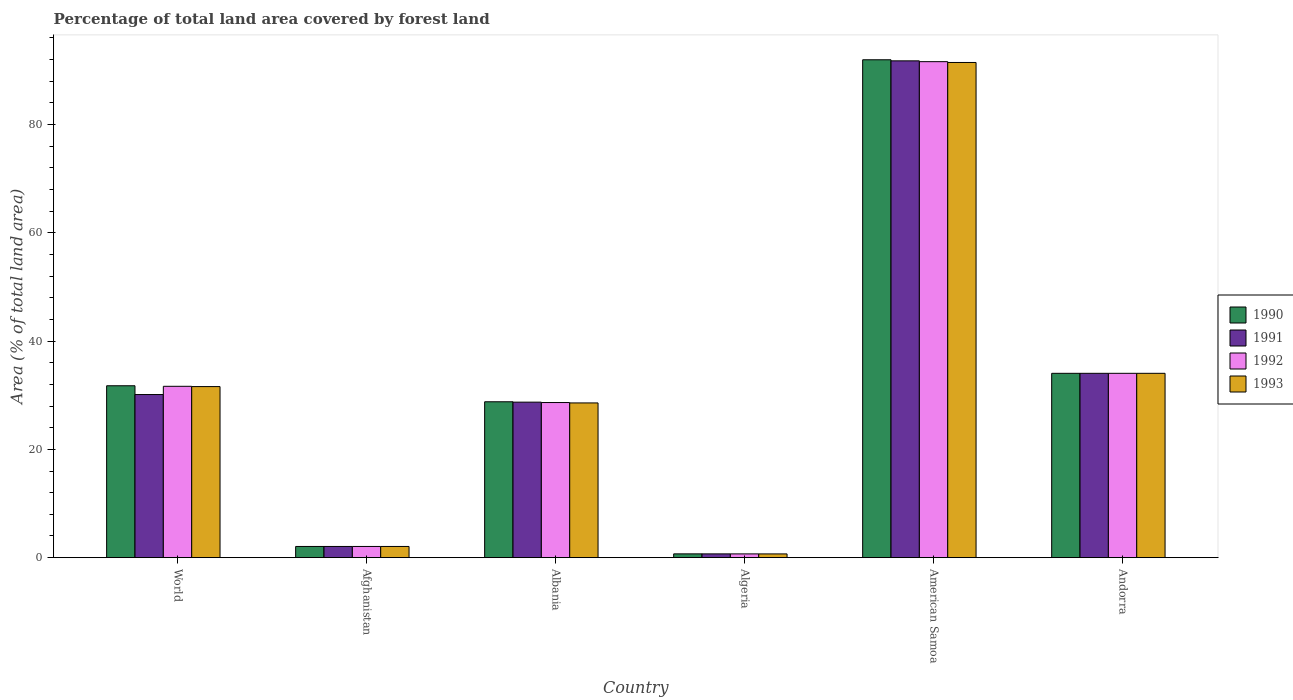How many different coloured bars are there?
Provide a succinct answer. 4. How many groups of bars are there?
Your answer should be compact. 6. Are the number of bars per tick equal to the number of legend labels?
Offer a very short reply. Yes. How many bars are there on the 6th tick from the left?
Your response must be concise. 4. How many bars are there on the 2nd tick from the right?
Keep it short and to the point. 4. What is the label of the 3rd group of bars from the left?
Offer a terse response. Albania. In how many cases, is the number of bars for a given country not equal to the number of legend labels?
Provide a succinct answer. 0. What is the percentage of forest land in 1993 in Albania?
Offer a very short reply. 28.57. Across all countries, what is the maximum percentage of forest land in 1990?
Offer a terse response. 91.95. Across all countries, what is the minimum percentage of forest land in 1992?
Keep it short and to the point. 0.69. In which country was the percentage of forest land in 1991 maximum?
Your answer should be compact. American Samoa. In which country was the percentage of forest land in 1993 minimum?
Offer a very short reply. Algeria. What is the total percentage of forest land in 1991 in the graph?
Give a very brief answer. 187.4. What is the difference between the percentage of forest land in 1993 in Afghanistan and that in World?
Give a very brief answer. -29.53. What is the difference between the percentage of forest land in 1991 in American Samoa and the percentage of forest land in 1990 in Algeria?
Your response must be concise. 91.05. What is the average percentage of forest land in 1993 per country?
Offer a terse response. 31.4. In how many countries, is the percentage of forest land in 1993 greater than 16 %?
Give a very brief answer. 4. What is the ratio of the percentage of forest land in 1991 in Afghanistan to that in World?
Give a very brief answer. 0.07. Is the percentage of forest land in 1991 in Albania less than that in Algeria?
Your answer should be compact. No. Is the difference between the percentage of forest land in 1990 in Afghanistan and Albania greater than the difference between the percentage of forest land in 1991 in Afghanistan and Albania?
Offer a very short reply. No. What is the difference between the highest and the second highest percentage of forest land in 1990?
Keep it short and to the point. -57.91. What is the difference between the highest and the lowest percentage of forest land in 1991?
Make the answer very short. 91.05. What does the 1st bar from the left in Afghanistan represents?
Keep it short and to the point. 1990. How many countries are there in the graph?
Your response must be concise. 6. Are the values on the major ticks of Y-axis written in scientific E-notation?
Provide a short and direct response. No. Does the graph contain any zero values?
Make the answer very short. No. Where does the legend appear in the graph?
Provide a short and direct response. Center right. How are the legend labels stacked?
Offer a terse response. Vertical. What is the title of the graph?
Offer a very short reply. Percentage of total land area covered by forest land. Does "1990" appear as one of the legend labels in the graph?
Make the answer very short. Yes. What is the label or title of the X-axis?
Make the answer very short. Country. What is the label or title of the Y-axis?
Ensure brevity in your answer.  Area (% of total land area). What is the Area (% of total land area) of 1990 in World?
Your response must be concise. 31.75. What is the Area (% of total land area) of 1991 in World?
Ensure brevity in your answer.  30.12. What is the Area (% of total land area) in 1992 in World?
Give a very brief answer. 31.64. What is the Area (% of total land area) of 1993 in World?
Ensure brevity in your answer.  31.59. What is the Area (% of total land area) of 1990 in Afghanistan?
Your answer should be compact. 2.07. What is the Area (% of total land area) in 1991 in Afghanistan?
Provide a succinct answer. 2.07. What is the Area (% of total land area) of 1992 in Afghanistan?
Your answer should be compact. 2.07. What is the Area (% of total land area) in 1993 in Afghanistan?
Ensure brevity in your answer.  2.07. What is the Area (% of total land area) of 1990 in Albania?
Your answer should be compact. 28.79. What is the Area (% of total land area) in 1991 in Albania?
Make the answer very short. 28.72. What is the Area (% of total land area) in 1992 in Albania?
Make the answer very short. 28.65. What is the Area (% of total land area) in 1993 in Albania?
Make the answer very short. 28.57. What is the Area (% of total land area) in 1990 in Algeria?
Ensure brevity in your answer.  0.7. What is the Area (% of total land area) of 1991 in Algeria?
Keep it short and to the point. 0.7. What is the Area (% of total land area) in 1992 in Algeria?
Your answer should be compact. 0.69. What is the Area (% of total land area) of 1993 in Algeria?
Make the answer very short. 0.69. What is the Area (% of total land area) of 1990 in American Samoa?
Give a very brief answer. 91.95. What is the Area (% of total land area) of 1991 in American Samoa?
Offer a terse response. 91.75. What is the Area (% of total land area) in 1992 in American Samoa?
Offer a very short reply. 91.6. What is the Area (% of total land area) in 1993 in American Samoa?
Ensure brevity in your answer.  91.45. What is the Area (% of total land area) in 1990 in Andorra?
Ensure brevity in your answer.  34.04. What is the Area (% of total land area) of 1991 in Andorra?
Give a very brief answer. 34.04. What is the Area (% of total land area) in 1992 in Andorra?
Offer a terse response. 34.04. What is the Area (% of total land area) of 1993 in Andorra?
Give a very brief answer. 34.04. Across all countries, what is the maximum Area (% of total land area) in 1990?
Your answer should be compact. 91.95. Across all countries, what is the maximum Area (% of total land area) of 1991?
Your answer should be very brief. 91.75. Across all countries, what is the maximum Area (% of total land area) of 1992?
Offer a very short reply. 91.6. Across all countries, what is the maximum Area (% of total land area) of 1993?
Offer a terse response. 91.45. Across all countries, what is the minimum Area (% of total land area) in 1990?
Your answer should be compact. 0.7. Across all countries, what is the minimum Area (% of total land area) of 1991?
Give a very brief answer. 0.7. Across all countries, what is the minimum Area (% of total land area) of 1992?
Make the answer very short. 0.69. Across all countries, what is the minimum Area (% of total land area) of 1993?
Provide a succinct answer. 0.69. What is the total Area (% of total land area) in 1990 in the graph?
Ensure brevity in your answer.  189.29. What is the total Area (% of total land area) of 1991 in the graph?
Offer a very short reply. 187.4. What is the total Area (% of total land area) of 1992 in the graph?
Your response must be concise. 188.69. What is the total Area (% of total land area) in 1993 in the graph?
Your answer should be very brief. 188.42. What is the difference between the Area (% of total land area) of 1990 in World and that in Afghanistan?
Provide a short and direct response. 29.68. What is the difference between the Area (% of total land area) in 1991 in World and that in Afghanistan?
Offer a very short reply. 28.06. What is the difference between the Area (% of total land area) in 1992 in World and that in Afghanistan?
Offer a very short reply. 29.58. What is the difference between the Area (% of total land area) of 1993 in World and that in Afghanistan?
Your response must be concise. 29.53. What is the difference between the Area (% of total land area) of 1990 in World and that in Albania?
Your answer should be compact. 2.96. What is the difference between the Area (% of total land area) of 1991 in World and that in Albania?
Ensure brevity in your answer.  1.41. What is the difference between the Area (% of total land area) of 1992 in World and that in Albania?
Offer a terse response. 3. What is the difference between the Area (% of total land area) in 1993 in World and that in Albania?
Ensure brevity in your answer.  3.02. What is the difference between the Area (% of total land area) of 1990 in World and that in Algeria?
Ensure brevity in your answer.  31.05. What is the difference between the Area (% of total land area) in 1991 in World and that in Algeria?
Make the answer very short. 29.43. What is the difference between the Area (% of total land area) in 1992 in World and that in Algeria?
Provide a succinct answer. 30.95. What is the difference between the Area (% of total land area) in 1993 in World and that in Algeria?
Offer a very short reply. 30.91. What is the difference between the Area (% of total land area) of 1990 in World and that in American Samoa?
Give a very brief answer. -60.2. What is the difference between the Area (% of total land area) of 1991 in World and that in American Samoa?
Make the answer very short. -61.63. What is the difference between the Area (% of total land area) of 1992 in World and that in American Samoa?
Your answer should be compact. -59.96. What is the difference between the Area (% of total land area) of 1993 in World and that in American Samoa?
Ensure brevity in your answer.  -59.86. What is the difference between the Area (% of total land area) of 1990 in World and that in Andorra?
Your response must be concise. -2.3. What is the difference between the Area (% of total land area) of 1991 in World and that in Andorra?
Offer a very short reply. -3.92. What is the difference between the Area (% of total land area) of 1992 in World and that in Andorra?
Give a very brief answer. -2.4. What is the difference between the Area (% of total land area) of 1993 in World and that in Andorra?
Make the answer very short. -2.45. What is the difference between the Area (% of total land area) of 1990 in Afghanistan and that in Albania?
Give a very brief answer. -26.72. What is the difference between the Area (% of total land area) in 1991 in Afghanistan and that in Albania?
Give a very brief answer. -26.65. What is the difference between the Area (% of total land area) in 1992 in Afghanistan and that in Albania?
Give a very brief answer. -26.58. What is the difference between the Area (% of total land area) in 1993 in Afghanistan and that in Albania?
Provide a short and direct response. -26.51. What is the difference between the Area (% of total land area) in 1990 in Afghanistan and that in Algeria?
Offer a very short reply. 1.37. What is the difference between the Area (% of total land area) in 1991 in Afghanistan and that in Algeria?
Ensure brevity in your answer.  1.37. What is the difference between the Area (% of total land area) of 1992 in Afghanistan and that in Algeria?
Your answer should be compact. 1.38. What is the difference between the Area (% of total land area) in 1993 in Afghanistan and that in Algeria?
Offer a terse response. 1.38. What is the difference between the Area (% of total land area) in 1990 in Afghanistan and that in American Samoa?
Your answer should be compact. -89.88. What is the difference between the Area (% of total land area) of 1991 in Afghanistan and that in American Samoa?
Ensure brevity in your answer.  -89.68. What is the difference between the Area (% of total land area) in 1992 in Afghanistan and that in American Samoa?
Offer a terse response. -89.53. What is the difference between the Area (% of total land area) of 1993 in Afghanistan and that in American Samoa?
Provide a succinct answer. -89.38. What is the difference between the Area (% of total land area) of 1990 in Afghanistan and that in Andorra?
Provide a succinct answer. -31.97. What is the difference between the Area (% of total land area) in 1991 in Afghanistan and that in Andorra?
Provide a succinct answer. -31.97. What is the difference between the Area (% of total land area) of 1992 in Afghanistan and that in Andorra?
Offer a terse response. -31.97. What is the difference between the Area (% of total land area) of 1993 in Afghanistan and that in Andorra?
Your answer should be very brief. -31.97. What is the difference between the Area (% of total land area) of 1990 in Albania and that in Algeria?
Offer a very short reply. 28.09. What is the difference between the Area (% of total land area) of 1991 in Albania and that in Algeria?
Offer a terse response. 28.02. What is the difference between the Area (% of total land area) in 1992 in Albania and that in Algeria?
Your answer should be very brief. 27.95. What is the difference between the Area (% of total land area) in 1993 in Albania and that in Algeria?
Ensure brevity in your answer.  27.89. What is the difference between the Area (% of total land area) of 1990 in Albania and that in American Samoa?
Your answer should be compact. -63.16. What is the difference between the Area (% of total land area) in 1991 in Albania and that in American Samoa?
Your answer should be compact. -63.03. What is the difference between the Area (% of total land area) of 1992 in Albania and that in American Samoa?
Your answer should be compact. -62.95. What is the difference between the Area (% of total land area) of 1993 in Albania and that in American Samoa?
Provide a succinct answer. -62.88. What is the difference between the Area (% of total land area) in 1990 in Albania and that in Andorra?
Your response must be concise. -5.25. What is the difference between the Area (% of total land area) of 1991 in Albania and that in Andorra?
Give a very brief answer. -5.33. What is the difference between the Area (% of total land area) of 1992 in Albania and that in Andorra?
Keep it short and to the point. -5.4. What is the difference between the Area (% of total land area) of 1993 in Albania and that in Andorra?
Ensure brevity in your answer.  -5.47. What is the difference between the Area (% of total land area) of 1990 in Algeria and that in American Samoa?
Your answer should be compact. -91.25. What is the difference between the Area (% of total land area) of 1991 in Algeria and that in American Samoa?
Give a very brief answer. -91.05. What is the difference between the Area (% of total land area) of 1992 in Algeria and that in American Samoa?
Your response must be concise. -90.91. What is the difference between the Area (% of total land area) in 1993 in Algeria and that in American Samoa?
Offer a terse response. -90.76. What is the difference between the Area (% of total land area) of 1990 in Algeria and that in Andorra?
Provide a succinct answer. -33.34. What is the difference between the Area (% of total land area) of 1991 in Algeria and that in Andorra?
Make the answer very short. -33.35. What is the difference between the Area (% of total land area) of 1992 in Algeria and that in Andorra?
Keep it short and to the point. -33.35. What is the difference between the Area (% of total land area) of 1993 in Algeria and that in Andorra?
Your response must be concise. -33.35. What is the difference between the Area (% of total land area) in 1990 in American Samoa and that in Andorra?
Keep it short and to the point. 57.91. What is the difference between the Area (% of total land area) in 1991 in American Samoa and that in Andorra?
Ensure brevity in your answer.  57.71. What is the difference between the Area (% of total land area) of 1992 in American Samoa and that in Andorra?
Offer a terse response. 57.56. What is the difference between the Area (% of total land area) of 1993 in American Samoa and that in Andorra?
Offer a terse response. 57.41. What is the difference between the Area (% of total land area) in 1990 in World and the Area (% of total land area) in 1991 in Afghanistan?
Provide a succinct answer. 29.68. What is the difference between the Area (% of total land area) of 1990 in World and the Area (% of total land area) of 1992 in Afghanistan?
Give a very brief answer. 29.68. What is the difference between the Area (% of total land area) of 1990 in World and the Area (% of total land area) of 1993 in Afghanistan?
Provide a succinct answer. 29.68. What is the difference between the Area (% of total land area) of 1991 in World and the Area (% of total land area) of 1992 in Afghanistan?
Give a very brief answer. 28.06. What is the difference between the Area (% of total land area) of 1991 in World and the Area (% of total land area) of 1993 in Afghanistan?
Provide a short and direct response. 28.06. What is the difference between the Area (% of total land area) of 1992 in World and the Area (% of total land area) of 1993 in Afghanistan?
Make the answer very short. 29.58. What is the difference between the Area (% of total land area) of 1990 in World and the Area (% of total land area) of 1991 in Albania?
Offer a very short reply. 3.03. What is the difference between the Area (% of total land area) in 1990 in World and the Area (% of total land area) in 1992 in Albania?
Keep it short and to the point. 3.1. What is the difference between the Area (% of total land area) of 1990 in World and the Area (% of total land area) of 1993 in Albania?
Your answer should be very brief. 3.17. What is the difference between the Area (% of total land area) of 1991 in World and the Area (% of total land area) of 1992 in Albania?
Ensure brevity in your answer.  1.48. What is the difference between the Area (% of total land area) of 1991 in World and the Area (% of total land area) of 1993 in Albania?
Your response must be concise. 1.55. What is the difference between the Area (% of total land area) in 1992 in World and the Area (% of total land area) in 1993 in Albania?
Your response must be concise. 3.07. What is the difference between the Area (% of total land area) of 1990 in World and the Area (% of total land area) of 1991 in Algeria?
Make the answer very short. 31.05. What is the difference between the Area (% of total land area) of 1990 in World and the Area (% of total land area) of 1992 in Algeria?
Keep it short and to the point. 31.05. What is the difference between the Area (% of total land area) of 1990 in World and the Area (% of total land area) of 1993 in Algeria?
Make the answer very short. 31.06. What is the difference between the Area (% of total land area) of 1991 in World and the Area (% of total land area) of 1992 in Algeria?
Your answer should be compact. 29.43. What is the difference between the Area (% of total land area) of 1991 in World and the Area (% of total land area) of 1993 in Algeria?
Provide a succinct answer. 29.44. What is the difference between the Area (% of total land area) in 1992 in World and the Area (% of total land area) in 1993 in Algeria?
Ensure brevity in your answer.  30.96. What is the difference between the Area (% of total land area) of 1990 in World and the Area (% of total land area) of 1991 in American Samoa?
Provide a short and direct response. -60. What is the difference between the Area (% of total land area) in 1990 in World and the Area (% of total land area) in 1992 in American Samoa?
Ensure brevity in your answer.  -59.85. What is the difference between the Area (% of total land area) of 1990 in World and the Area (% of total land area) of 1993 in American Samoa?
Keep it short and to the point. -59.7. What is the difference between the Area (% of total land area) of 1991 in World and the Area (% of total land area) of 1992 in American Samoa?
Ensure brevity in your answer.  -61.48. What is the difference between the Area (% of total land area) in 1991 in World and the Area (% of total land area) in 1993 in American Samoa?
Your answer should be very brief. -61.33. What is the difference between the Area (% of total land area) of 1992 in World and the Area (% of total land area) of 1993 in American Samoa?
Offer a terse response. -59.81. What is the difference between the Area (% of total land area) of 1990 in World and the Area (% of total land area) of 1991 in Andorra?
Offer a very short reply. -2.3. What is the difference between the Area (% of total land area) in 1990 in World and the Area (% of total land area) in 1992 in Andorra?
Your answer should be compact. -2.3. What is the difference between the Area (% of total land area) of 1990 in World and the Area (% of total land area) of 1993 in Andorra?
Keep it short and to the point. -2.3. What is the difference between the Area (% of total land area) in 1991 in World and the Area (% of total land area) in 1992 in Andorra?
Offer a very short reply. -3.92. What is the difference between the Area (% of total land area) of 1991 in World and the Area (% of total land area) of 1993 in Andorra?
Make the answer very short. -3.92. What is the difference between the Area (% of total land area) of 1992 in World and the Area (% of total land area) of 1993 in Andorra?
Make the answer very short. -2.4. What is the difference between the Area (% of total land area) of 1990 in Afghanistan and the Area (% of total land area) of 1991 in Albania?
Give a very brief answer. -26.65. What is the difference between the Area (% of total land area) in 1990 in Afghanistan and the Area (% of total land area) in 1992 in Albania?
Provide a short and direct response. -26.58. What is the difference between the Area (% of total land area) in 1990 in Afghanistan and the Area (% of total land area) in 1993 in Albania?
Give a very brief answer. -26.51. What is the difference between the Area (% of total land area) of 1991 in Afghanistan and the Area (% of total land area) of 1992 in Albania?
Your answer should be very brief. -26.58. What is the difference between the Area (% of total land area) in 1991 in Afghanistan and the Area (% of total land area) in 1993 in Albania?
Your response must be concise. -26.51. What is the difference between the Area (% of total land area) of 1992 in Afghanistan and the Area (% of total land area) of 1993 in Albania?
Provide a short and direct response. -26.51. What is the difference between the Area (% of total land area) in 1990 in Afghanistan and the Area (% of total land area) in 1991 in Algeria?
Give a very brief answer. 1.37. What is the difference between the Area (% of total land area) of 1990 in Afghanistan and the Area (% of total land area) of 1992 in Algeria?
Keep it short and to the point. 1.38. What is the difference between the Area (% of total land area) in 1990 in Afghanistan and the Area (% of total land area) in 1993 in Algeria?
Ensure brevity in your answer.  1.38. What is the difference between the Area (% of total land area) in 1991 in Afghanistan and the Area (% of total land area) in 1992 in Algeria?
Provide a succinct answer. 1.38. What is the difference between the Area (% of total land area) of 1991 in Afghanistan and the Area (% of total land area) of 1993 in Algeria?
Your response must be concise. 1.38. What is the difference between the Area (% of total land area) in 1992 in Afghanistan and the Area (% of total land area) in 1993 in Algeria?
Your answer should be very brief. 1.38. What is the difference between the Area (% of total land area) of 1990 in Afghanistan and the Area (% of total land area) of 1991 in American Samoa?
Offer a very short reply. -89.68. What is the difference between the Area (% of total land area) in 1990 in Afghanistan and the Area (% of total land area) in 1992 in American Samoa?
Your answer should be very brief. -89.53. What is the difference between the Area (% of total land area) of 1990 in Afghanistan and the Area (% of total land area) of 1993 in American Samoa?
Ensure brevity in your answer.  -89.38. What is the difference between the Area (% of total land area) in 1991 in Afghanistan and the Area (% of total land area) in 1992 in American Samoa?
Offer a very short reply. -89.53. What is the difference between the Area (% of total land area) of 1991 in Afghanistan and the Area (% of total land area) of 1993 in American Samoa?
Your response must be concise. -89.38. What is the difference between the Area (% of total land area) of 1992 in Afghanistan and the Area (% of total land area) of 1993 in American Samoa?
Keep it short and to the point. -89.38. What is the difference between the Area (% of total land area) in 1990 in Afghanistan and the Area (% of total land area) in 1991 in Andorra?
Ensure brevity in your answer.  -31.97. What is the difference between the Area (% of total land area) in 1990 in Afghanistan and the Area (% of total land area) in 1992 in Andorra?
Your answer should be very brief. -31.97. What is the difference between the Area (% of total land area) in 1990 in Afghanistan and the Area (% of total land area) in 1993 in Andorra?
Ensure brevity in your answer.  -31.97. What is the difference between the Area (% of total land area) of 1991 in Afghanistan and the Area (% of total land area) of 1992 in Andorra?
Offer a very short reply. -31.97. What is the difference between the Area (% of total land area) of 1991 in Afghanistan and the Area (% of total land area) of 1993 in Andorra?
Offer a terse response. -31.97. What is the difference between the Area (% of total land area) of 1992 in Afghanistan and the Area (% of total land area) of 1993 in Andorra?
Your response must be concise. -31.97. What is the difference between the Area (% of total land area) in 1990 in Albania and the Area (% of total land area) in 1991 in Algeria?
Offer a very short reply. 28.09. What is the difference between the Area (% of total land area) in 1990 in Albania and the Area (% of total land area) in 1992 in Algeria?
Make the answer very short. 28.1. What is the difference between the Area (% of total land area) of 1990 in Albania and the Area (% of total land area) of 1993 in Algeria?
Ensure brevity in your answer.  28.1. What is the difference between the Area (% of total land area) in 1991 in Albania and the Area (% of total land area) in 1992 in Algeria?
Your answer should be compact. 28.02. What is the difference between the Area (% of total land area) of 1991 in Albania and the Area (% of total land area) of 1993 in Algeria?
Provide a succinct answer. 28.03. What is the difference between the Area (% of total land area) in 1992 in Albania and the Area (% of total land area) in 1993 in Algeria?
Offer a very short reply. 27.96. What is the difference between the Area (% of total land area) in 1990 in Albania and the Area (% of total land area) in 1991 in American Samoa?
Make the answer very short. -62.96. What is the difference between the Area (% of total land area) of 1990 in Albania and the Area (% of total land area) of 1992 in American Samoa?
Give a very brief answer. -62.81. What is the difference between the Area (% of total land area) in 1990 in Albania and the Area (% of total land area) in 1993 in American Samoa?
Ensure brevity in your answer.  -62.66. What is the difference between the Area (% of total land area) in 1991 in Albania and the Area (% of total land area) in 1992 in American Samoa?
Make the answer very short. -62.88. What is the difference between the Area (% of total land area) in 1991 in Albania and the Area (% of total land area) in 1993 in American Samoa?
Provide a short and direct response. -62.73. What is the difference between the Area (% of total land area) of 1992 in Albania and the Area (% of total land area) of 1993 in American Samoa?
Make the answer very short. -62.8. What is the difference between the Area (% of total land area) of 1990 in Albania and the Area (% of total land area) of 1991 in Andorra?
Ensure brevity in your answer.  -5.25. What is the difference between the Area (% of total land area) of 1990 in Albania and the Area (% of total land area) of 1992 in Andorra?
Make the answer very short. -5.25. What is the difference between the Area (% of total land area) in 1990 in Albania and the Area (% of total land area) in 1993 in Andorra?
Give a very brief answer. -5.25. What is the difference between the Area (% of total land area) of 1991 in Albania and the Area (% of total land area) of 1992 in Andorra?
Offer a very short reply. -5.33. What is the difference between the Area (% of total land area) of 1991 in Albania and the Area (% of total land area) of 1993 in Andorra?
Your answer should be compact. -5.33. What is the difference between the Area (% of total land area) of 1992 in Albania and the Area (% of total land area) of 1993 in Andorra?
Your answer should be very brief. -5.4. What is the difference between the Area (% of total land area) in 1990 in Algeria and the Area (% of total land area) in 1991 in American Samoa?
Offer a terse response. -91.05. What is the difference between the Area (% of total land area) of 1990 in Algeria and the Area (% of total land area) of 1992 in American Samoa?
Provide a succinct answer. -90.9. What is the difference between the Area (% of total land area) in 1990 in Algeria and the Area (% of total land area) in 1993 in American Samoa?
Your answer should be compact. -90.75. What is the difference between the Area (% of total land area) of 1991 in Algeria and the Area (% of total land area) of 1992 in American Samoa?
Your answer should be compact. -90.9. What is the difference between the Area (% of total land area) in 1991 in Algeria and the Area (% of total land area) in 1993 in American Samoa?
Offer a very short reply. -90.75. What is the difference between the Area (% of total land area) of 1992 in Algeria and the Area (% of total land area) of 1993 in American Samoa?
Offer a terse response. -90.76. What is the difference between the Area (% of total land area) in 1990 in Algeria and the Area (% of total land area) in 1991 in Andorra?
Give a very brief answer. -33.34. What is the difference between the Area (% of total land area) of 1990 in Algeria and the Area (% of total land area) of 1992 in Andorra?
Offer a very short reply. -33.34. What is the difference between the Area (% of total land area) in 1990 in Algeria and the Area (% of total land area) in 1993 in Andorra?
Offer a very short reply. -33.34. What is the difference between the Area (% of total land area) of 1991 in Algeria and the Area (% of total land area) of 1992 in Andorra?
Offer a terse response. -33.35. What is the difference between the Area (% of total land area) in 1991 in Algeria and the Area (% of total land area) in 1993 in Andorra?
Keep it short and to the point. -33.35. What is the difference between the Area (% of total land area) of 1992 in Algeria and the Area (% of total land area) of 1993 in Andorra?
Make the answer very short. -33.35. What is the difference between the Area (% of total land area) of 1990 in American Samoa and the Area (% of total land area) of 1991 in Andorra?
Ensure brevity in your answer.  57.91. What is the difference between the Area (% of total land area) in 1990 in American Samoa and the Area (% of total land area) in 1992 in Andorra?
Provide a short and direct response. 57.91. What is the difference between the Area (% of total land area) of 1990 in American Samoa and the Area (% of total land area) of 1993 in Andorra?
Give a very brief answer. 57.91. What is the difference between the Area (% of total land area) in 1991 in American Samoa and the Area (% of total land area) in 1992 in Andorra?
Provide a short and direct response. 57.71. What is the difference between the Area (% of total land area) of 1991 in American Samoa and the Area (% of total land area) of 1993 in Andorra?
Ensure brevity in your answer.  57.71. What is the difference between the Area (% of total land area) of 1992 in American Samoa and the Area (% of total land area) of 1993 in Andorra?
Your answer should be very brief. 57.56. What is the average Area (% of total land area) of 1990 per country?
Provide a short and direct response. 31.55. What is the average Area (% of total land area) of 1991 per country?
Give a very brief answer. 31.23. What is the average Area (% of total land area) of 1992 per country?
Keep it short and to the point. 31.45. What is the average Area (% of total land area) of 1993 per country?
Ensure brevity in your answer.  31.4. What is the difference between the Area (% of total land area) of 1990 and Area (% of total land area) of 1991 in World?
Your answer should be very brief. 1.62. What is the difference between the Area (% of total land area) of 1990 and Area (% of total land area) of 1992 in World?
Give a very brief answer. 0.1. What is the difference between the Area (% of total land area) in 1990 and Area (% of total land area) in 1993 in World?
Offer a terse response. 0.15. What is the difference between the Area (% of total land area) in 1991 and Area (% of total land area) in 1992 in World?
Provide a succinct answer. -1.52. What is the difference between the Area (% of total land area) in 1991 and Area (% of total land area) in 1993 in World?
Your response must be concise. -1.47. What is the difference between the Area (% of total land area) of 1992 and Area (% of total land area) of 1993 in World?
Provide a short and direct response. 0.05. What is the difference between the Area (% of total land area) of 1990 and Area (% of total land area) of 1991 in Afghanistan?
Provide a short and direct response. 0. What is the difference between the Area (% of total land area) of 1990 and Area (% of total land area) of 1992 in Afghanistan?
Your answer should be very brief. 0. What is the difference between the Area (% of total land area) in 1990 and Area (% of total land area) in 1993 in Afghanistan?
Give a very brief answer. 0. What is the difference between the Area (% of total land area) in 1991 and Area (% of total land area) in 1993 in Afghanistan?
Provide a succinct answer. 0. What is the difference between the Area (% of total land area) in 1992 and Area (% of total land area) in 1993 in Afghanistan?
Your response must be concise. 0. What is the difference between the Area (% of total land area) in 1990 and Area (% of total land area) in 1991 in Albania?
Provide a succinct answer. 0.07. What is the difference between the Area (% of total land area) of 1990 and Area (% of total land area) of 1992 in Albania?
Provide a short and direct response. 0.14. What is the difference between the Area (% of total land area) in 1990 and Area (% of total land area) in 1993 in Albania?
Offer a very short reply. 0.21. What is the difference between the Area (% of total land area) of 1991 and Area (% of total land area) of 1992 in Albania?
Provide a short and direct response. 0.07. What is the difference between the Area (% of total land area) of 1991 and Area (% of total land area) of 1993 in Albania?
Offer a very short reply. 0.14. What is the difference between the Area (% of total land area) in 1992 and Area (% of total land area) in 1993 in Albania?
Keep it short and to the point. 0.07. What is the difference between the Area (% of total land area) in 1990 and Area (% of total land area) in 1991 in Algeria?
Provide a short and direct response. 0. What is the difference between the Area (% of total land area) of 1990 and Area (% of total land area) of 1992 in Algeria?
Offer a terse response. 0.01. What is the difference between the Area (% of total land area) of 1990 and Area (% of total land area) of 1993 in Algeria?
Provide a succinct answer. 0.01. What is the difference between the Area (% of total land area) of 1991 and Area (% of total land area) of 1992 in Algeria?
Offer a terse response. 0. What is the difference between the Area (% of total land area) in 1991 and Area (% of total land area) in 1993 in Algeria?
Your answer should be compact. 0.01. What is the difference between the Area (% of total land area) of 1992 and Area (% of total land area) of 1993 in Algeria?
Offer a very short reply. 0. What is the difference between the Area (% of total land area) in 1991 and Area (% of total land area) in 1992 in American Samoa?
Give a very brief answer. 0.15. What is the difference between the Area (% of total land area) of 1990 and Area (% of total land area) of 1991 in Andorra?
Your response must be concise. 0. What is the difference between the Area (% of total land area) of 1990 and Area (% of total land area) of 1992 in Andorra?
Your response must be concise. 0. What is the difference between the Area (% of total land area) in 1991 and Area (% of total land area) in 1992 in Andorra?
Offer a terse response. 0. What is the difference between the Area (% of total land area) of 1991 and Area (% of total land area) of 1993 in Andorra?
Offer a terse response. 0. What is the difference between the Area (% of total land area) in 1992 and Area (% of total land area) in 1993 in Andorra?
Your answer should be compact. 0. What is the ratio of the Area (% of total land area) of 1990 in World to that in Afghanistan?
Your answer should be very brief. 15.35. What is the ratio of the Area (% of total land area) in 1991 in World to that in Afghanistan?
Your answer should be compact. 14.57. What is the ratio of the Area (% of total land area) of 1992 in World to that in Afghanistan?
Your answer should be very brief. 15.3. What is the ratio of the Area (% of total land area) of 1993 in World to that in Afghanistan?
Your answer should be compact. 15.28. What is the ratio of the Area (% of total land area) of 1990 in World to that in Albania?
Ensure brevity in your answer.  1.1. What is the ratio of the Area (% of total land area) of 1991 in World to that in Albania?
Offer a terse response. 1.05. What is the ratio of the Area (% of total land area) of 1992 in World to that in Albania?
Ensure brevity in your answer.  1.1. What is the ratio of the Area (% of total land area) of 1993 in World to that in Albania?
Provide a succinct answer. 1.11. What is the ratio of the Area (% of total land area) in 1990 in World to that in Algeria?
Ensure brevity in your answer.  45.36. What is the ratio of the Area (% of total land area) in 1991 in World to that in Algeria?
Give a very brief answer. 43.27. What is the ratio of the Area (% of total land area) of 1992 in World to that in Algeria?
Give a very brief answer. 45.7. What is the ratio of the Area (% of total land area) in 1993 in World to that in Algeria?
Provide a succinct answer. 45.87. What is the ratio of the Area (% of total land area) in 1990 in World to that in American Samoa?
Offer a very short reply. 0.35. What is the ratio of the Area (% of total land area) in 1991 in World to that in American Samoa?
Give a very brief answer. 0.33. What is the ratio of the Area (% of total land area) of 1992 in World to that in American Samoa?
Keep it short and to the point. 0.35. What is the ratio of the Area (% of total land area) in 1993 in World to that in American Samoa?
Your answer should be compact. 0.35. What is the ratio of the Area (% of total land area) of 1990 in World to that in Andorra?
Your response must be concise. 0.93. What is the ratio of the Area (% of total land area) in 1991 in World to that in Andorra?
Provide a short and direct response. 0.88. What is the ratio of the Area (% of total land area) in 1992 in World to that in Andorra?
Keep it short and to the point. 0.93. What is the ratio of the Area (% of total land area) in 1993 in World to that in Andorra?
Ensure brevity in your answer.  0.93. What is the ratio of the Area (% of total land area) in 1990 in Afghanistan to that in Albania?
Offer a terse response. 0.07. What is the ratio of the Area (% of total land area) of 1991 in Afghanistan to that in Albania?
Keep it short and to the point. 0.07. What is the ratio of the Area (% of total land area) of 1992 in Afghanistan to that in Albania?
Offer a terse response. 0.07. What is the ratio of the Area (% of total land area) of 1993 in Afghanistan to that in Albania?
Give a very brief answer. 0.07. What is the ratio of the Area (% of total land area) of 1990 in Afghanistan to that in Algeria?
Ensure brevity in your answer.  2.95. What is the ratio of the Area (% of total land area) in 1991 in Afghanistan to that in Algeria?
Provide a short and direct response. 2.97. What is the ratio of the Area (% of total land area) in 1992 in Afghanistan to that in Algeria?
Your answer should be compact. 2.99. What is the ratio of the Area (% of total land area) of 1993 in Afghanistan to that in Algeria?
Your answer should be compact. 3. What is the ratio of the Area (% of total land area) in 1990 in Afghanistan to that in American Samoa?
Offer a very short reply. 0.02. What is the ratio of the Area (% of total land area) in 1991 in Afghanistan to that in American Samoa?
Keep it short and to the point. 0.02. What is the ratio of the Area (% of total land area) in 1992 in Afghanistan to that in American Samoa?
Your response must be concise. 0.02. What is the ratio of the Area (% of total land area) of 1993 in Afghanistan to that in American Samoa?
Make the answer very short. 0.02. What is the ratio of the Area (% of total land area) in 1990 in Afghanistan to that in Andorra?
Provide a succinct answer. 0.06. What is the ratio of the Area (% of total land area) in 1991 in Afghanistan to that in Andorra?
Keep it short and to the point. 0.06. What is the ratio of the Area (% of total land area) in 1992 in Afghanistan to that in Andorra?
Provide a succinct answer. 0.06. What is the ratio of the Area (% of total land area) in 1993 in Afghanistan to that in Andorra?
Offer a terse response. 0.06. What is the ratio of the Area (% of total land area) in 1990 in Albania to that in Algeria?
Offer a terse response. 41.13. What is the ratio of the Area (% of total land area) in 1991 in Albania to that in Algeria?
Keep it short and to the point. 41.25. What is the ratio of the Area (% of total land area) in 1992 in Albania to that in Algeria?
Ensure brevity in your answer.  41.36. What is the ratio of the Area (% of total land area) in 1993 in Albania to that in Algeria?
Keep it short and to the point. 41.48. What is the ratio of the Area (% of total land area) in 1990 in Albania to that in American Samoa?
Your answer should be very brief. 0.31. What is the ratio of the Area (% of total land area) in 1991 in Albania to that in American Samoa?
Give a very brief answer. 0.31. What is the ratio of the Area (% of total land area) in 1992 in Albania to that in American Samoa?
Offer a very short reply. 0.31. What is the ratio of the Area (% of total land area) in 1993 in Albania to that in American Samoa?
Give a very brief answer. 0.31. What is the ratio of the Area (% of total land area) in 1990 in Albania to that in Andorra?
Keep it short and to the point. 0.85. What is the ratio of the Area (% of total land area) of 1991 in Albania to that in Andorra?
Give a very brief answer. 0.84. What is the ratio of the Area (% of total land area) in 1992 in Albania to that in Andorra?
Provide a succinct answer. 0.84. What is the ratio of the Area (% of total land area) of 1993 in Albania to that in Andorra?
Ensure brevity in your answer.  0.84. What is the ratio of the Area (% of total land area) in 1990 in Algeria to that in American Samoa?
Offer a very short reply. 0.01. What is the ratio of the Area (% of total land area) in 1991 in Algeria to that in American Samoa?
Give a very brief answer. 0.01. What is the ratio of the Area (% of total land area) in 1992 in Algeria to that in American Samoa?
Provide a short and direct response. 0.01. What is the ratio of the Area (% of total land area) of 1993 in Algeria to that in American Samoa?
Keep it short and to the point. 0.01. What is the ratio of the Area (% of total land area) of 1990 in Algeria to that in Andorra?
Your answer should be compact. 0.02. What is the ratio of the Area (% of total land area) of 1991 in Algeria to that in Andorra?
Ensure brevity in your answer.  0.02. What is the ratio of the Area (% of total land area) of 1992 in Algeria to that in Andorra?
Your answer should be compact. 0.02. What is the ratio of the Area (% of total land area) in 1993 in Algeria to that in Andorra?
Provide a short and direct response. 0.02. What is the ratio of the Area (% of total land area) in 1990 in American Samoa to that in Andorra?
Offer a very short reply. 2.7. What is the ratio of the Area (% of total land area) in 1991 in American Samoa to that in Andorra?
Keep it short and to the point. 2.7. What is the ratio of the Area (% of total land area) in 1992 in American Samoa to that in Andorra?
Give a very brief answer. 2.69. What is the ratio of the Area (% of total land area) of 1993 in American Samoa to that in Andorra?
Provide a succinct answer. 2.69. What is the difference between the highest and the second highest Area (% of total land area) of 1990?
Offer a terse response. 57.91. What is the difference between the highest and the second highest Area (% of total land area) of 1991?
Provide a short and direct response. 57.71. What is the difference between the highest and the second highest Area (% of total land area) of 1992?
Offer a very short reply. 57.56. What is the difference between the highest and the second highest Area (% of total land area) in 1993?
Provide a succinct answer. 57.41. What is the difference between the highest and the lowest Area (% of total land area) in 1990?
Your answer should be very brief. 91.25. What is the difference between the highest and the lowest Area (% of total land area) of 1991?
Offer a very short reply. 91.05. What is the difference between the highest and the lowest Area (% of total land area) of 1992?
Provide a short and direct response. 90.91. What is the difference between the highest and the lowest Area (% of total land area) in 1993?
Give a very brief answer. 90.76. 